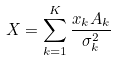<formula> <loc_0><loc_0><loc_500><loc_500>X = \sum _ { k = 1 } ^ { K } \frac { x _ { k } A _ { k } } { \sigma _ { k } ^ { 2 } }</formula> 